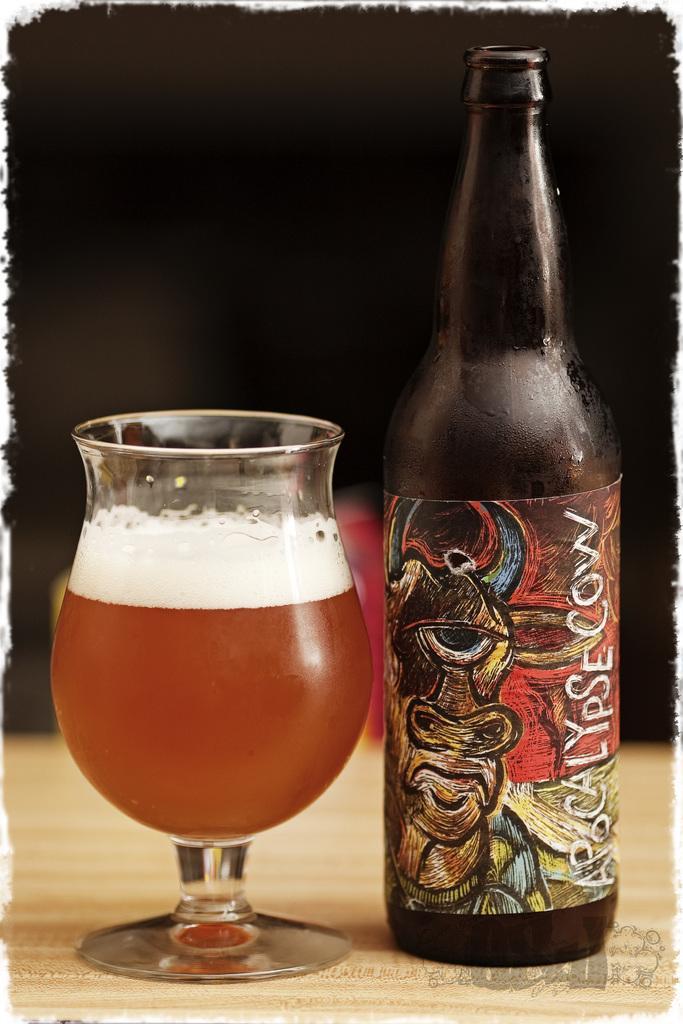Describe this image in one or two sentences. In this image we can see a glass with a drink in it and a bottle with a label on it are placed on the wooden surface. The background of the image is dark. 